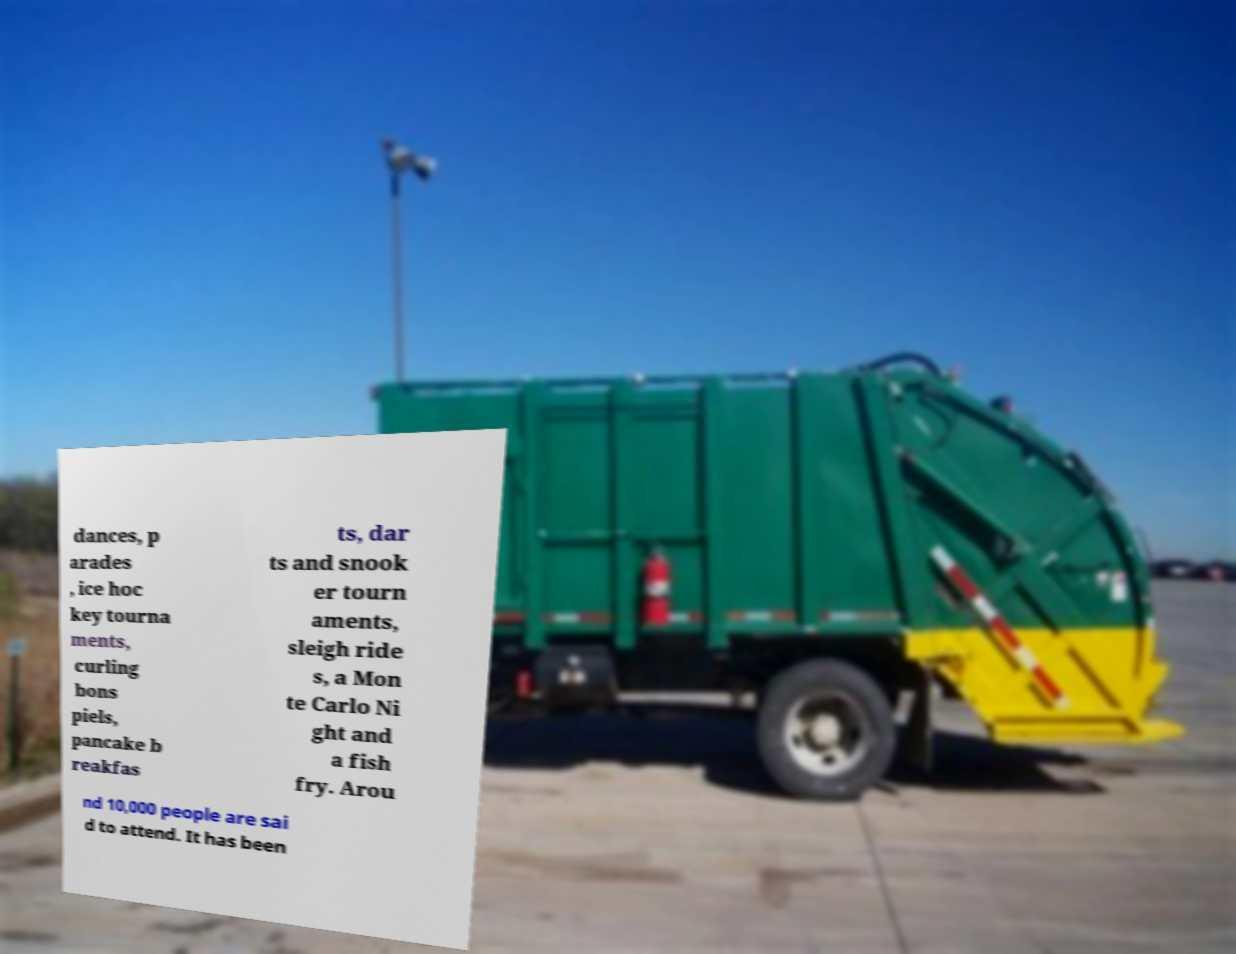Can you accurately transcribe the text from the provided image for me? dances, p arades , ice hoc key tourna ments, curling bons piels, pancake b reakfas ts, dar ts and snook er tourn aments, sleigh ride s, a Mon te Carlo Ni ght and a fish fry. Arou nd 10,000 people are sai d to attend. It has been 